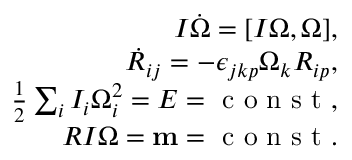Convert formula to latex. <formula><loc_0><loc_0><loc_500><loc_500>\begin{array} { r } { I \dot { \boldsymbol \Omega } = [ I { \boldsymbol \Omega } , { \boldsymbol \Omega } ] , } \\ { \dot { R } _ { i j } = - \epsilon _ { j k p } \Omega _ { k } R _ { i p } , } \\ { \frac { 1 } { 2 } \sum _ { i } I _ { i } \Omega _ { i } ^ { 2 } = E = c o n s t , } \\ { R I { \boldsymbol \Omega } = { m } = c o n s t . } \end{array}</formula> 